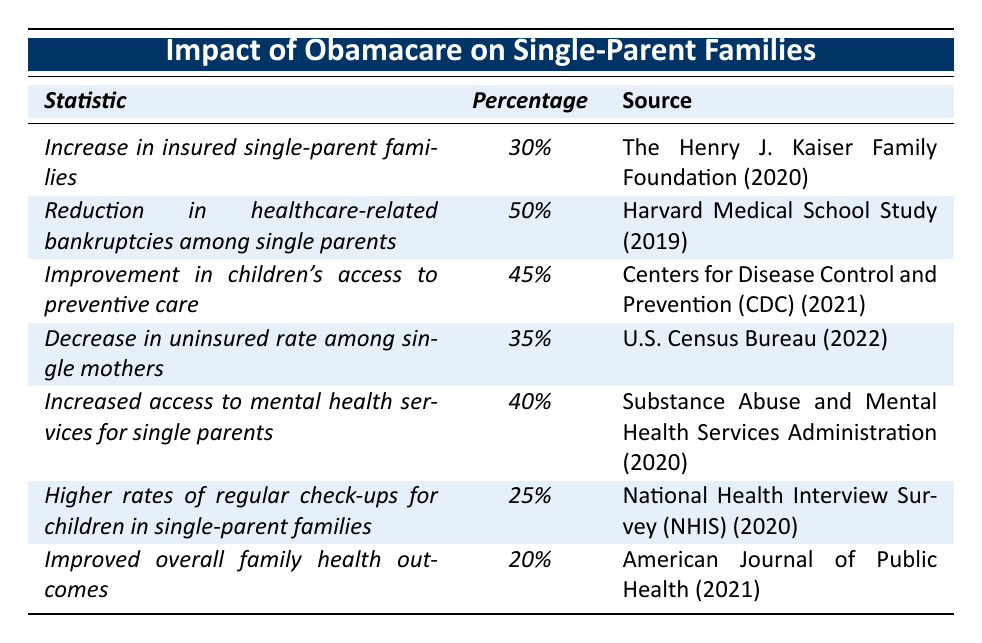What percentage of single-parent families are now insured after Obamacare? According to the table, the statistic for the increase in insured single-parent families is 30%. Therefore, this clearly indicates the percentage.
Answer: 30% What is the percentage reduction in healthcare-related bankruptcies among single parents? The table specifically notes a 50% reduction in healthcare-related bankruptcies among single parents. This statistic is direct and available in the table.
Answer: 50% Which source documents the improvement in children's access to preventive care? The table states that the Centers for Disease Control and Prevention (CDC) in 2021 reported a 45% improvement in children's access to preventive care.
Answer: Centers for Disease Control and Prevention (CDC) (2021) Is there a higher rate of regular check-ups for children in single-parent families compared to overall family health outcomes? Yes, the table indicates that higher rates of regular check-ups for children in single-parent families is 25%, whereas the improved overall family health outcomes is 20%. Therefore, it confirms that regular check-ups is higher.
Answer: Yes What is the average percentage improvement for the statistics mentioned regarding single-parent families? To calculate the average: (30 + 50 + 45 + 35 + 40 + 25 + 20) / 7 = 35.71%. This is calculated by summing the percentages which totals 250 and then dividing by 7, the number of statistics.
Answer: 35.71% Are the percentages of improved access to mental health services and decreased uninsured rates among single mothers equal? No, the access to mental health services for single parents is 40%, while the decrease in uninsured rates among single mothers is 35%. This clearly shows they are not equal.
Answer: No What is the difference between the percentage of improvement in children's access to preventive care and the overall family health outcomes? The improvement in children's access to preventive care is 45%, and overall family health outcomes improvement is 20%. Thus, the difference is calculated as 45% - 20% = 25%.
Answer: 25% What conclusions can be made about the impact of Obamacare on single parents when looking at both the decrease in uninsured rate and the increase in insured families? The table shows a 35% decrease in uninsured rates among single mothers and a 30% increase in insured single-parent families. This suggests a significant improvement in healthcare coverage for single-parent families, indicating that more families now have access to insurance.
Answer: Significant improvement in healthcare coverage 